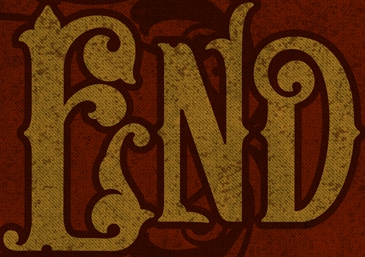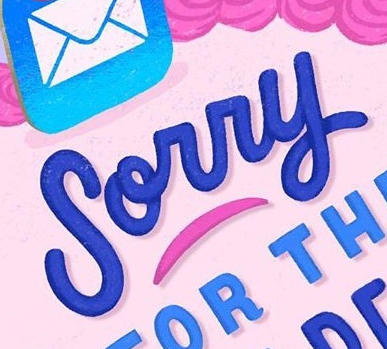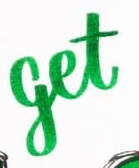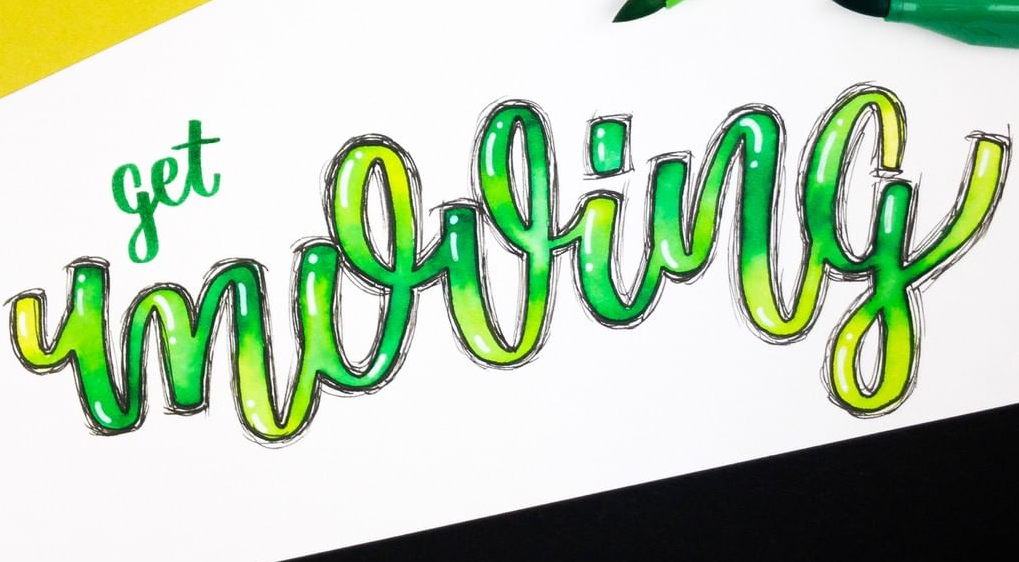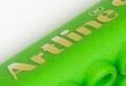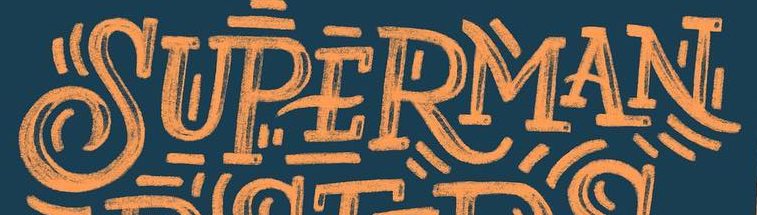Transcribe the words shown in these images in order, separated by a semicolon. END; Sorry; get; mooing; Artline; SUPERMAN 